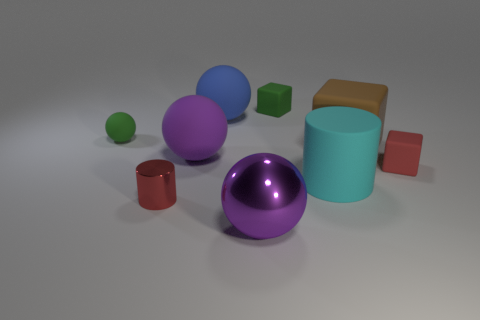Subtract all cylinders. How many objects are left? 7 Subtract all large purple rubber spheres. Subtract all green rubber blocks. How many objects are left? 7 Add 3 large brown rubber things. How many large brown rubber things are left? 4 Add 3 blue rubber spheres. How many blue rubber spheres exist? 4 Subtract 0 yellow cylinders. How many objects are left? 9 